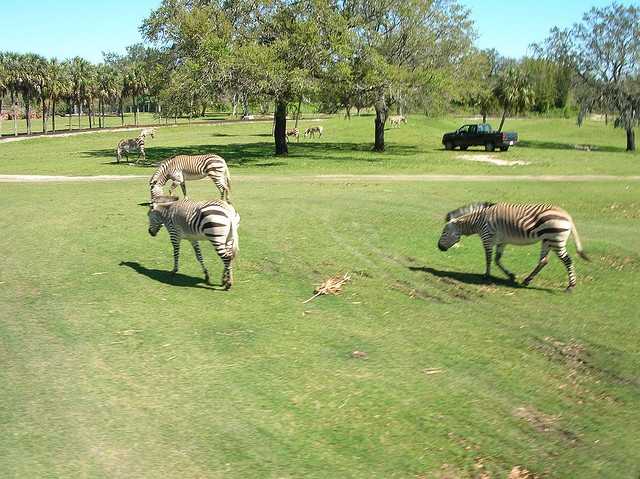Describe the objects in this image and their specific colors. I can see zebra in lightblue, gray, black, olive, and darkgreen tones, zebra in lightblue, gray, ivory, black, and tan tones, zebra in lightblue, beige, and tan tones, truck in lightblue, black, gray, teal, and green tones, and zebra in lightblue, gray, darkgreen, black, and tan tones in this image. 